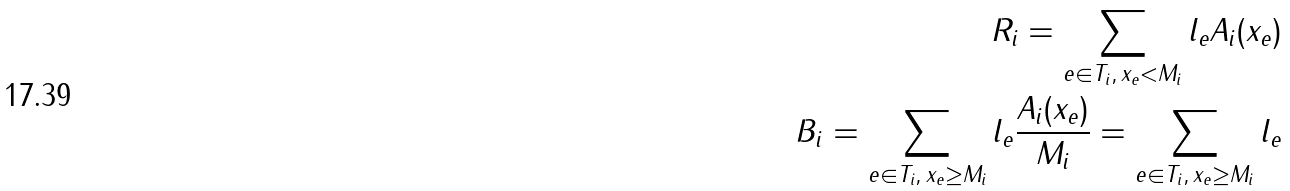Convert formula to latex. <formula><loc_0><loc_0><loc_500><loc_500>R _ { i } = \sum _ { e \in T _ { i } , \, x _ { e } < M _ { i } } l _ { e } A _ { i } ( x _ { e } ) \\ B _ { i } = \sum _ { e \in T _ { i } , \, x _ { e } \geq M _ { i } } l _ { e } \frac { A _ { i } ( x _ { e } ) } { M _ { i } } = \sum _ { e \in T _ { i } , \, x _ { e } \geq M _ { i } } l _ { e }</formula> 